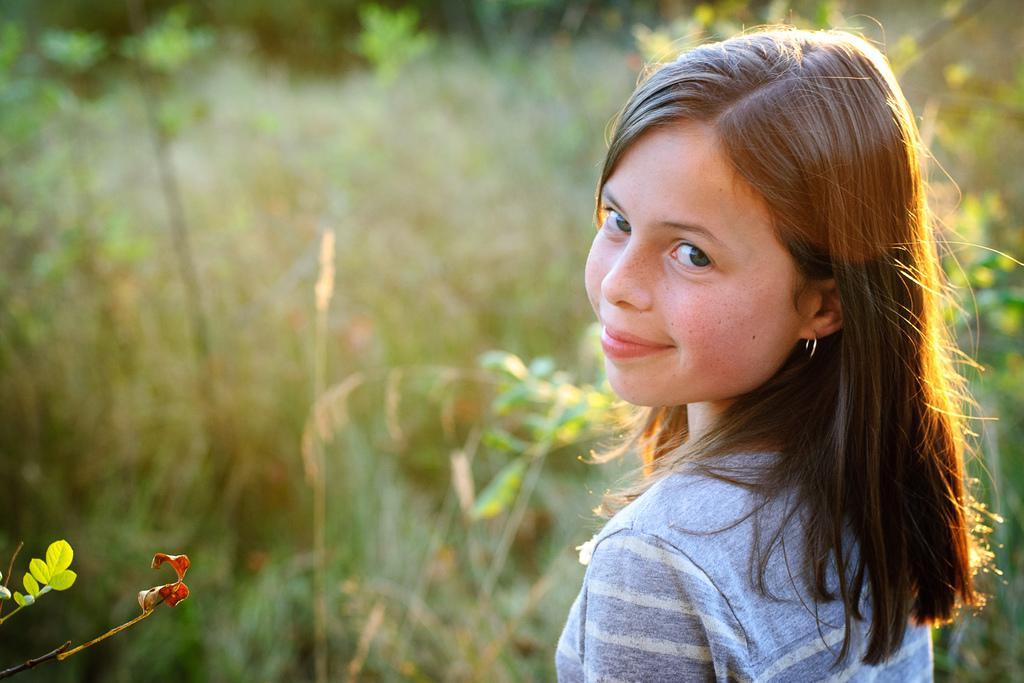Who is the main subject in the image? There is a girl in the image. What is the girl's expression in the image? The girl is smiling in the image. Can you describe the background of the image? The background of the image is blurred and green. What can be seen in the bottom left side of the image? There are leaves visible in the bottom left side of the image. What type of connection can be seen between the girl and the plants in the image? There are no plants visible in the image, only leaves in the bottom left side. What kind of shoes is the girl wearing in the image? The girl's shoes are not visible in the image. 